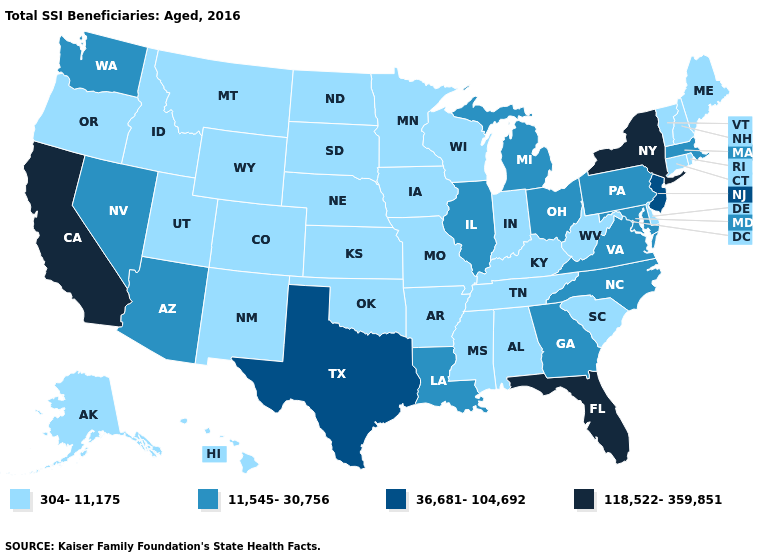What is the lowest value in the USA?
Give a very brief answer. 304-11,175. Does Oklahoma have a lower value than Iowa?
Be succinct. No. Name the states that have a value in the range 304-11,175?
Keep it brief. Alabama, Alaska, Arkansas, Colorado, Connecticut, Delaware, Hawaii, Idaho, Indiana, Iowa, Kansas, Kentucky, Maine, Minnesota, Mississippi, Missouri, Montana, Nebraska, New Hampshire, New Mexico, North Dakota, Oklahoma, Oregon, Rhode Island, South Carolina, South Dakota, Tennessee, Utah, Vermont, West Virginia, Wisconsin, Wyoming. What is the value of Wyoming?
Be succinct. 304-11,175. Does Massachusetts have a lower value than Louisiana?
Be succinct. No. Does the first symbol in the legend represent the smallest category?
Concise answer only. Yes. What is the value of Utah?
Quick response, please. 304-11,175. What is the value of California?
Give a very brief answer. 118,522-359,851. Name the states that have a value in the range 304-11,175?
Concise answer only. Alabama, Alaska, Arkansas, Colorado, Connecticut, Delaware, Hawaii, Idaho, Indiana, Iowa, Kansas, Kentucky, Maine, Minnesota, Mississippi, Missouri, Montana, Nebraska, New Hampshire, New Mexico, North Dakota, Oklahoma, Oregon, Rhode Island, South Carolina, South Dakota, Tennessee, Utah, Vermont, West Virginia, Wisconsin, Wyoming. What is the value of Utah?
Be succinct. 304-11,175. How many symbols are there in the legend?
Write a very short answer. 4. What is the value of North Carolina?
Answer briefly. 11,545-30,756. Which states hav the highest value in the South?
Write a very short answer. Florida. Name the states that have a value in the range 36,681-104,692?
Short answer required. New Jersey, Texas. Name the states that have a value in the range 11,545-30,756?
Short answer required. Arizona, Georgia, Illinois, Louisiana, Maryland, Massachusetts, Michigan, Nevada, North Carolina, Ohio, Pennsylvania, Virginia, Washington. 